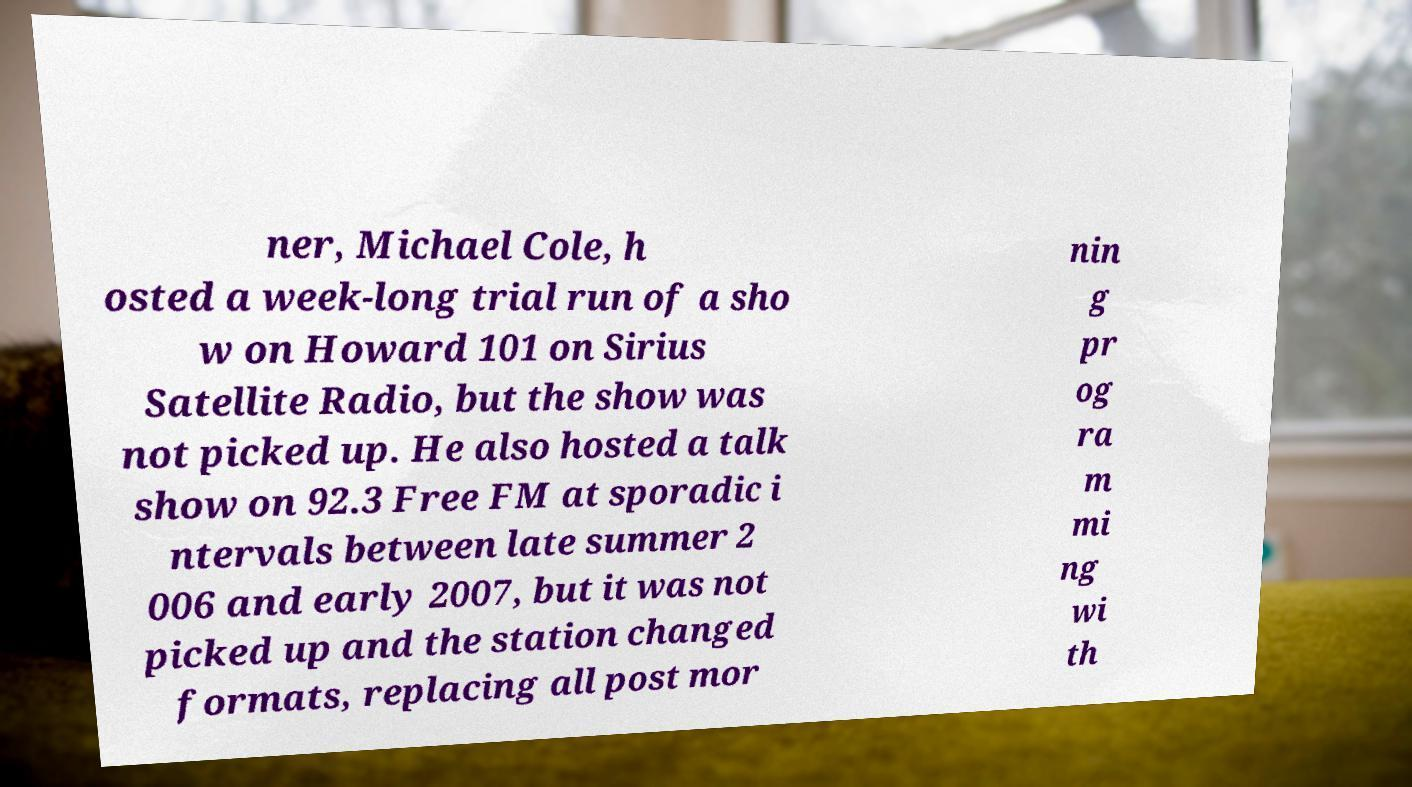Can you read and provide the text displayed in the image?This photo seems to have some interesting text. Can you extract and type it out for me? ner, Michael Cole, h osted a week-long trial run of a sho w on Howard 101 on Sirius Satellite Radio, but the show was not picked up. He also hosted a talk show on 92.3 Free FM at sporadic i ntervals between late summer 2 006 and early 2007, but it was not picked up and the station changed formats, replacing all post mor nin g pr og ra m mi ng wi th 